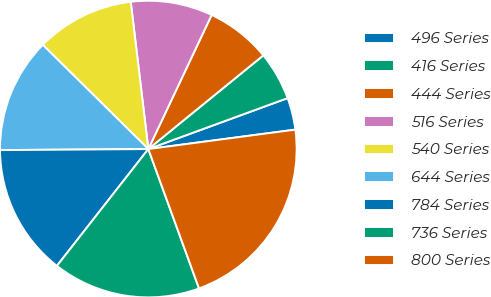Convert chart to OTSL. <chart><loc_0><loc_0><loc_500><loc_500><pie_chart><fcel>496 Series<fcel>416 Series<fcel>444 Series<fcel>516 Series<fcel>540 Series<fcel>644 Series<fcel>784 Series<fcel>736 Series<fcel>800 Series<nl><fcel>3.49%<fcel>5.3%<fcel>7.1%<fcel>8.91%<fcel>10.71%<fcel>12.51%<fcel>14.32%<fcel>16.12%<fcel>21.54%<nl></chart> 